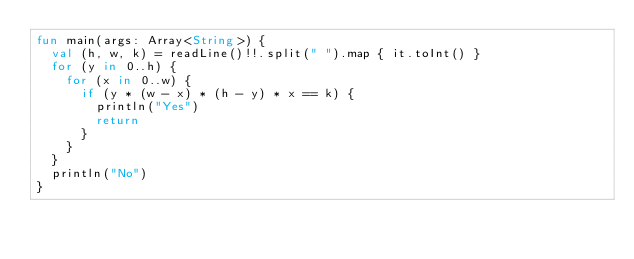Convert code to text. <code><loc_0><loc_0><loc_500><loc_500><_Kotlin_>fun main(args: Array<String>) {
  val (h, w, k) = readLine()!!.split(" ").map { it.toInt() }
  for (y in 0..h) {
    for (x in 0..w) {
      if (y * (w - x) * (h - y) * x == k) {
        println("Yes")
        return
      }
    }
  }
  println("No")
}
</code> 